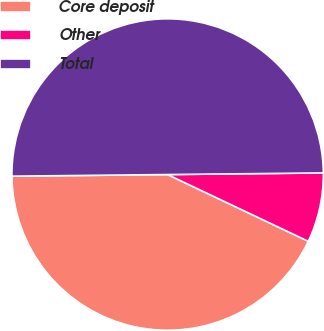Convert chart. <chart><loc_0><loc_0><loc_500><loc_500><pie_chart><fcel>Core deposit<fcel>Other<fcel>Total<nl><fcel>42.78%<fcel>7.22%<fcel>50.0%<nl></chart> 